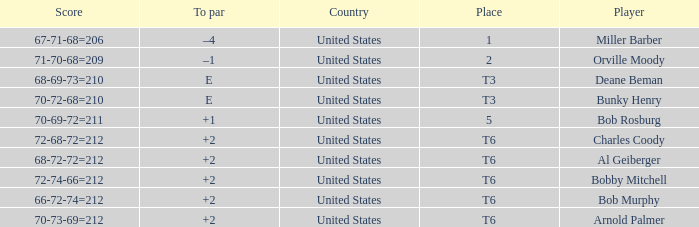Who is the player with a t6 place and a 72-68-72=212 score? Charles Coody. 